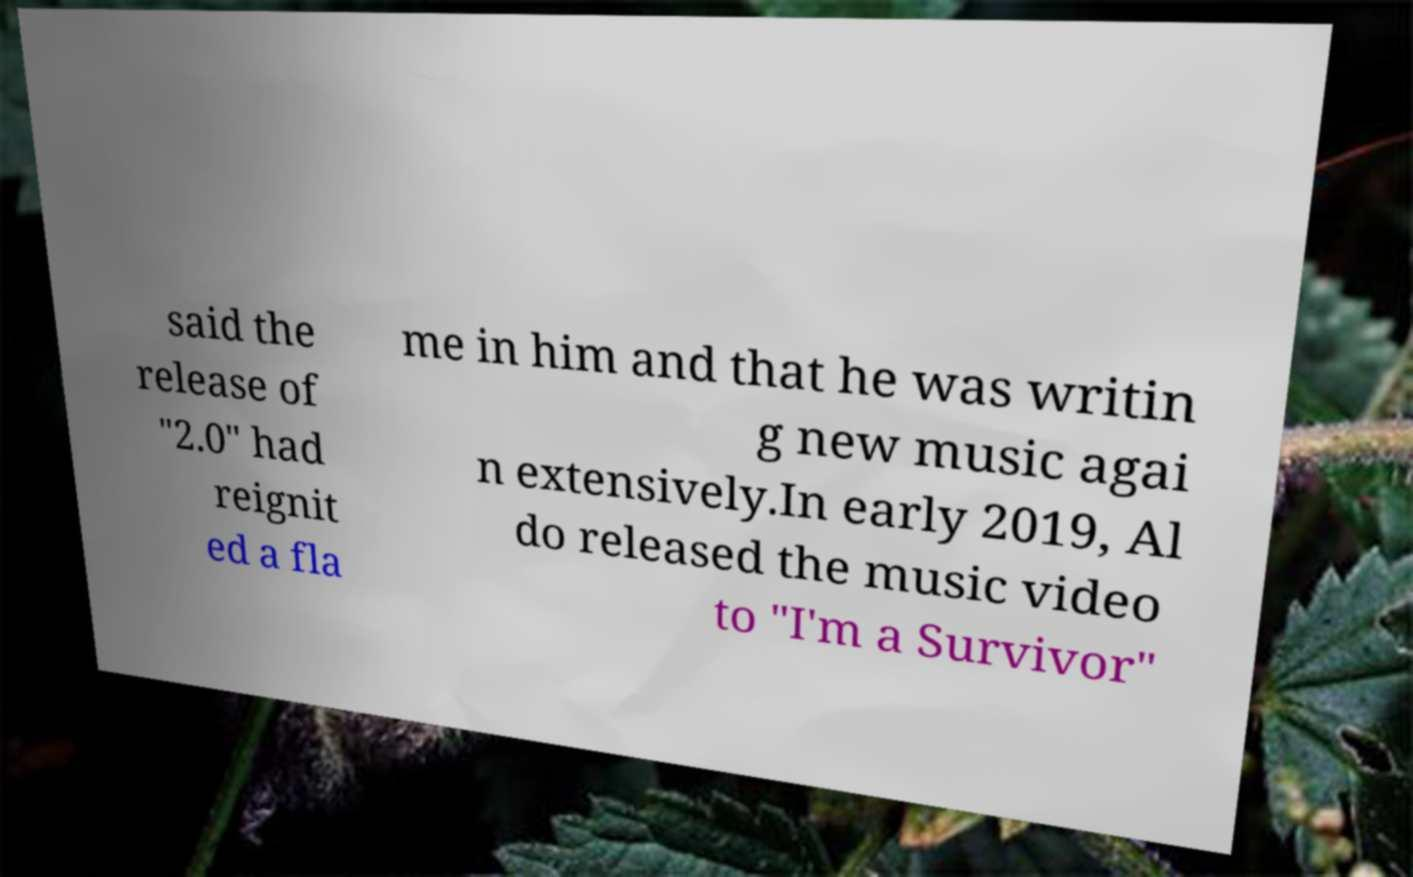There's text embedded in this image that I need extracted. Can you transcribe it verbatim? said the release of "2.0" had reignit ed a fla me in him and that he was writin g new music agai n extensively.In early 2019, Al do released the music video to "I'm a Survivor" 